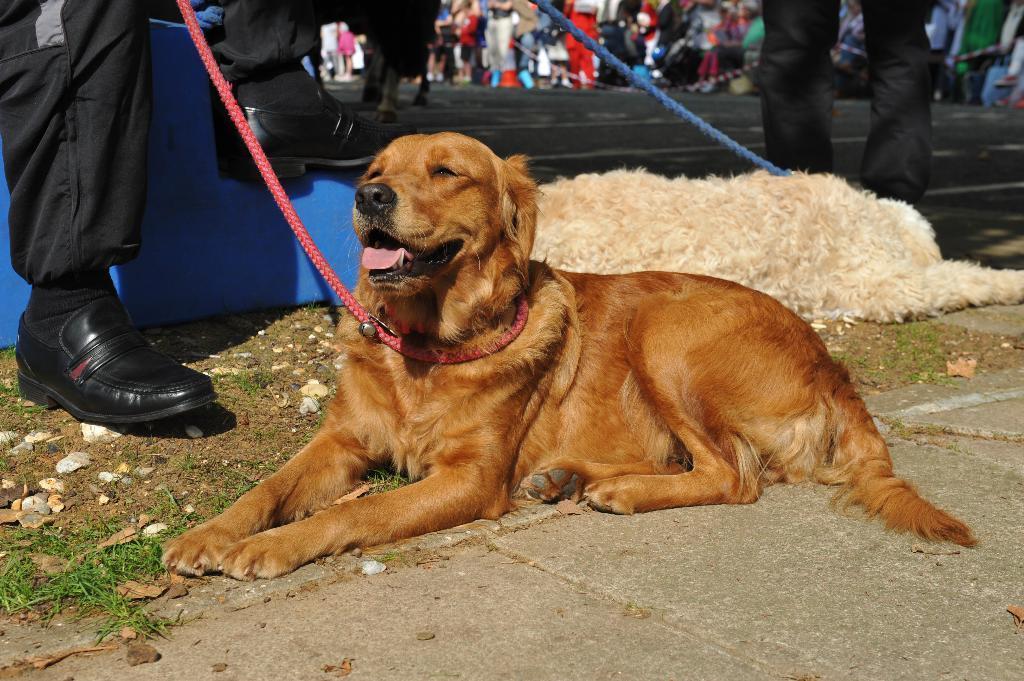Please provide a concise description of this image. In this image we can see dogs and there are people. We can see a road. 